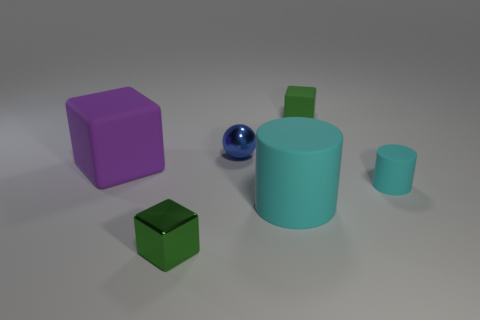What is the size of the matte cylinder that is behind the large rubber object to the right of the tiny metallic block?
Ensure brevity in your answer.  Small. Is the shape of the thing that is left of the green metal thing the same as  the blue object?
Give a very brief answer. No. What is the material of the other cyan object that is the same shape as the large cyan thing?
Your answer should be very brief. Rubber. How many things are either green cubes to the right of the tiny metallic ball or small cubes in front of the green rubber object?
Make the answer very short. 2. There is a tiny rubber cylinder; is it the same color as the large rubber thing that is right of the blue metallic sphere?
Provide a succinct answer. Yes. What shape is the big cyan object that is made of the same material as the purple thing?
Provide a short and direct response. Cylinder. What number of green objects are there?
Ensure brevity in your answer.  2. How many things are either rubber cubes behind the purple block or gray cylinders?
Keep it short and to the point. 1. There is a big thing to the right of the small metal cube; is its color the same as the small cylinder?
Your response must be concise. Yes. How many other things are there of the same color as the tiny matte block?
Offer a terse response. 1. 